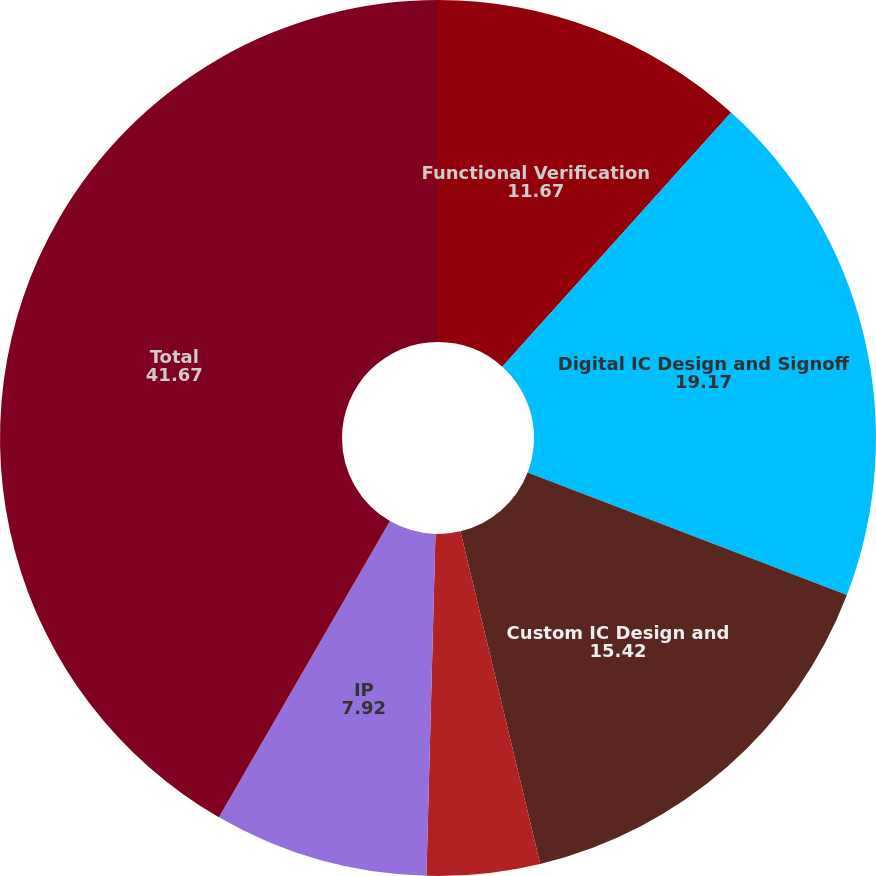<chart> <loc_0><loc_0><loc_500><loc_500><pie_chart><fcel>Functional Verification<fcel>Digital IC Design and Signoff<fcel>Custom IC Design and<fcel>System Interconnect and<fcel>IP<fcel>Total<nl><fcel>11.67%<fcel>19.17%<fcel>15.42%<fcel>4.17%<fcel>7.92%<fcel>41.67%<nl></chart> 